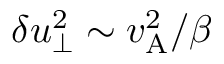Convert formula to latex. <formula><loc_0><loc_0><loc_500><loc_500>\delta u _ { \perp } ^ { 2 } \sim v _ { A } ^ { 2 } / \beta</formula> 